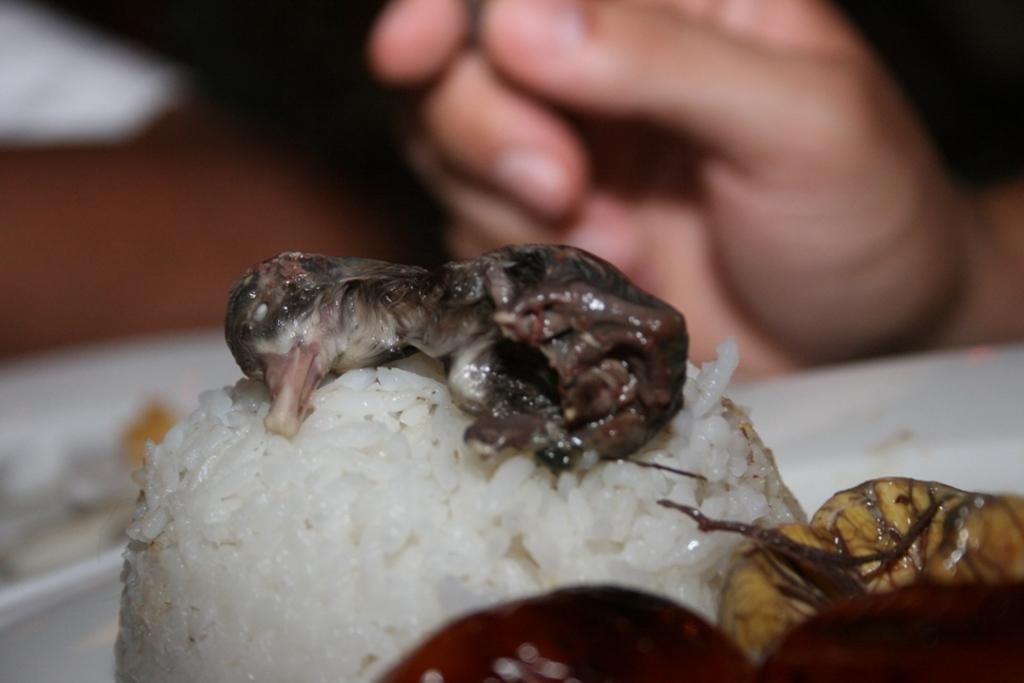What is on the plate in the image? There is food in the plate in the image. Can you describe any other elements in the image? A human hand is visible in the image. How many ants can be seen carrying the food in the image? There are no ants present in the image, and therefore no ants are carrying the food. What type of star is visible in the image? There is no star visible in the image; it is a close-up of a plate of food and a human hand. 